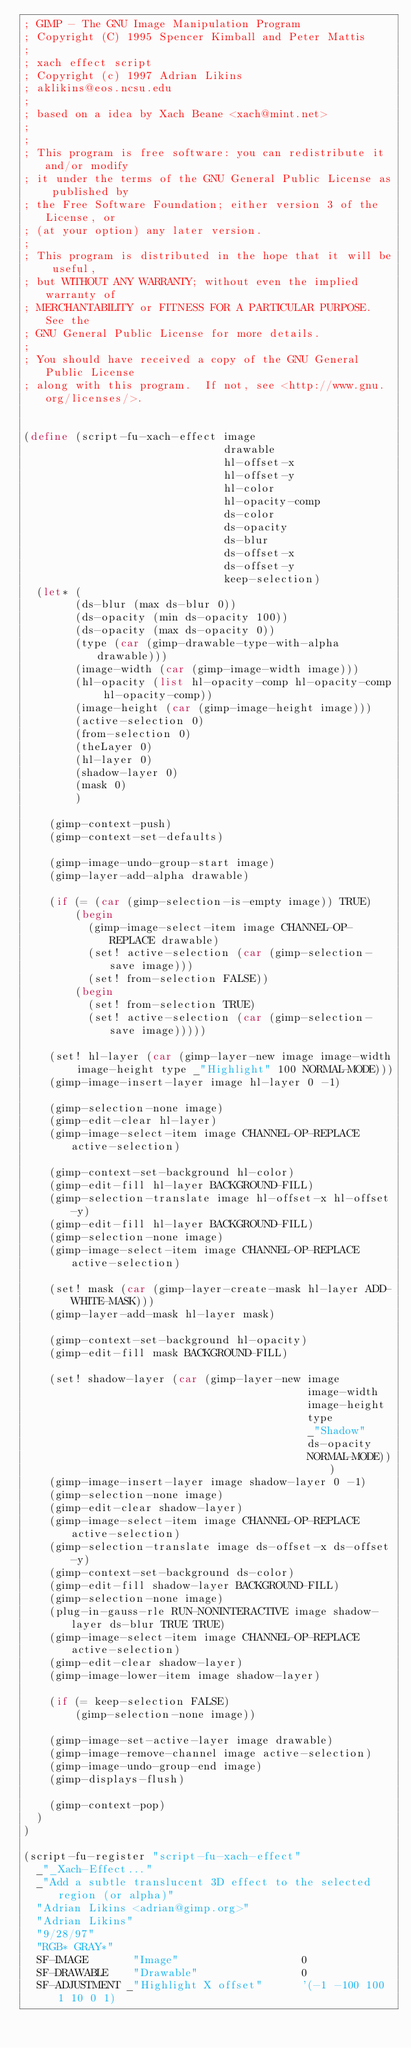Convert code to text. <code><loc_0><loc_0><loc_500><loc_500><_Scheme_>; GIMP - The GNU Image Manipulation Program
; Copyright (C) 1995 Spencer Kimball and Peter Mattis
;
; xach effect script
; Copyright (c) 1997 Adrian Likins
; aklikins@eos.ncsu.edu
;
; based on a idea by Xach Beane <xach@mint.net>
;
;
; This program is free software: you can redistribute it and/or modify
; it under the terms of the GNU General Public License as published by
; the Free Software Foundation; either version 3 of the License, or
; (at your option) any later version.
;
; This program is distributed in the hope that it will be useful,
; but WITHOUT ANY WARRANTY; without even the implied warranty of
; MERCHANTABILITY or FITNESS FOR A PARTICULAR PURPOSE.  See the
; GNU General Public License for more details.
;
; You should have received a copy of the GNU General Public License
; along with this program.  If not, see <http://www.gnu.org/licenses/>.


(define (script-fu-xach-effect image
                               drawable
                               hl-offset-x
                               hl-offset-y
                               hl-color
                               hl-opacity-comp
                               ds-color
                               ds-opacity
                               ds-blur
                               ds-offset-x
                               ds-offset-y
                               keep-selection)
  (let* (
        (ds-blur (max ds-blur 0))
        (ds-opacity (min ds-opacity 100))
        (ds-opacity (max ds-opacity 0))
        (type (car (gimp-drawable-type-with-alpha drawable)))
        (image-width (car (gimp-image-width image)))
        (hl-opacity (list hl-opacity-comp hl-opacity-comp hl-opacity-comp))
        (image-height (car (gimp-image-height image)))
        (active-selection 0)
        (from-selection 0)
        (theLayer 0)
        (hl-layer 0)
        (shadow-layer 0)
        (mask 0)
        )

    (gimp-context-push)
    (gimp-context-set-defaults)

    (gimp-image-undo-group-start image)
    (gimp-layer-add-alpha drawable)

    (if (= (car (gimp-selection-is-empty image)) TRUE)
        (begin
          (gimp-image-select-item image CHANNEL-OP-REPLACE drawable)
          (set! active-selection (car (gimp-selection-save image)))
          (set! from-selection FALSE))
        (begin
          (set! from-selection TRUE)
          (set! active-selection (car (gimp-selection-save image)))))

    (set! hl-layer (car (gimp-layer-new image image-width image-height type _"Highlight" 100 NORMAL-MODE)))
    (gimp-image-insert-layer image hl-layer 0 -1)

    (gimp-selection-none image)
    (gimp-edit-clear hl-layer)
    (gimp-image-select-item image CHANNEL-OP-REPLACE active-selection)

    (gimp-context-set-background hl-color)
    (gimp-edit-fill hl-layer BACKGROUND-FILL)
    (gimp-selection-translate image hl-offset-x hl-offset-y)
    (gimp-edit-fill hl-layer BACKGROUND-FILL)
    (gimp-selection-none image)
    (gimp-image-select-item image CHANNEL-OP-REPLACE active-selection)

    (set! mask (car (gimp-layer-create-mask hl-layer ADD-WHITE-MASK)))
    (gimp-layer-add-mask hl-layer mask)

    (gimp-context-set-background hl-opacity)
    (gimp-edit-fill mask BACKGROUND-FILL)

    (set! shadow-layer (car (gimp-layer-new image
                                            image-width
                                            image-height
                                            type
                                            _"Shadow"
                                            ds-opacity
                                            NORMAL-MODE)))
    (gimp-image-insert-layer image shadow-layer 0 -1)
    (gimp-selection-none image)
    (gimp-edit-clear shadow-layer)
    (gimp-image-select-item image CHANNEL-OP-REPLACE active-selection)
    (gimp-selection-translate image ds-offset-x ds-offset-y)
    (gimp-context-set-background ds-color)
    (gimp-edit-fill shadow-layer BACKGROUND-FILL)
    (gimp-selection-none image)
    (plug-in-gauss-rle RUN-NONINTERACTIVE image shadow-layer ds-blur TRUE TRUE)
    (gimp-image-select-item image CHANNEL-OP-REPLACE active-selection)
    (gimp-edit-clear shadow-layer)
    (gimp-image-lower-item image shadow-layer)

    (if (= keep-selection FALSE)
        (gimp-selection-none image))

    (gimp-image-set-active-layer image drawable)
    (gimp-image-remove-channel image active-selection)
    (gimp-image-undo-group-end image)
    (gimp-displays-flush)

    (gimp-context-pop)
  )
)

(script-fu-register "script-fu-xach-effect"
  _"_Xach-Effect..."
  _"Add a subtle translucent 3D effect to the selected region (or alpha)"
  "Adrian Likins <adrian@gimp.org>"
  "Adrian Likins"
  "9/28/97"
  "RGB* GRAY*"
  SF-IMAGE       "Image"                   0
  SF-DRAWABLE    "Drawable"                0
  SF-ADJUSTMENT _"Highlight X offset"      '(-1 -100 100 1 10 0 1)</code> 